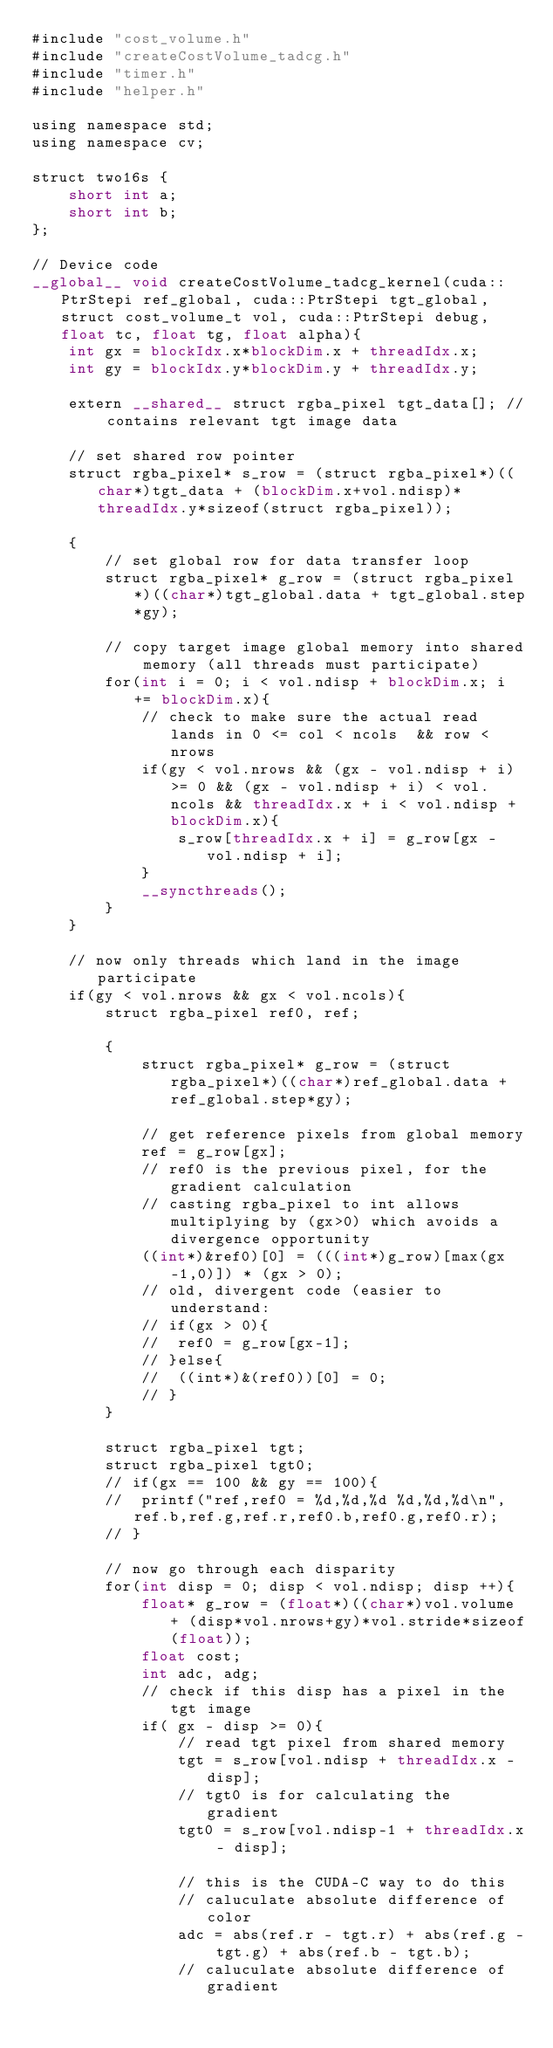<code> <loc_0><loc_0><loc_500><loc_500><_Cuda_>#include "cost_volume.h"
#include "createCostVolume_tadcg.h"
#include "timer.h"
#include "helper.h"

using namespace std;
using namespace cv;

struct two16s {
	short int a;
	short int b;
};

// Device code
__global__ void createCostVolume_tadcg_kernel(cuda::PtrStepi ref_global, cuda::PtrStepi tgt_global, struct cost_volume_t vol, cuda::PtrStepi debug, float tc, float tg, float alpha){
	int gx = blockIdx.x*blockDim.x + threadIdx.x;
	int gy = blockIdx.y*blockDim.y + threadIdx.y;

	extern __shared__ struct rgba_pixel tgt_data[]; // contains relevant tgt image data

	// set shared row pointer
	struct rgba_pixel* s_row = (struct rgba_pixel*)((char*)tgt_data + (blockDim.x+vol.ndisp)*threadIdx.y*sizeof(struct rgba_pixel));
	
	{
		// set global row for data transfer loop
		struct rgba_pixel* g_row = (struct rgba_pixel*)((char*)tgt_global.data + tgt_global.step*gy);

		// copy target image global memory into shared memory (all threads must participate)
		for(int i = 0; i < vol.ndisp + blockDim.x; i += blockDim.x){
			// check to make sure the actual read lands in 0 <= col < ncols  && row < nrows
			if(gy < vol.nrows && (gx - vol.ndisp + i) >= 0 && (gx - vol.ndisp + i) < vol.ncols && threadIdx.x + i < vol.ndisp + blockDim.x){
				s_row[threadIdx.x + i] = g_row[gx - vol.ndisp + i];
			}
			__syncthreads();
		}
	}

	// now only threads which land in the image participate
	if(gy < vol.nrows && gx < vol.ncols){
		struct rgba_pixel ref0, ref;

		{
			struct rgba_pixel* g_row = (struct rgba_pixel*)((char*)ref_global.data + ref_global.step*gy);

			// get reference pixels from global memory
			ref = g_row[gx];
			// ref0 is the previous pixel, for the gradient calculation
			// casting rgba_pixel to int allows multiplying by (gx>0) which avoids a divergence opportunity
			((int*)&ref0)[0] = (((int*)g_row)[max(gx-1,0)]) * (gx > 0);
			// old, divergent code (easier to understand:
			// if(gx > 0){
			// 	ref0 = g_row[gx-1];
			// }else{
			// 	((int*)&(ref0))[0] = 0;
			// }
		} 

		struct rgba_pixel tgt;
		struct rgba_pixel tgt0;
		// if(gx == 100 && gy == 100){
		// 	printf("ref,ref0 = %d,%d,%d %d,%d,%d\n",ref.b,ref.g,ref.r,ref0.b,ref0.g,ref0.r);
		// }

		// now go through each disparity
		for(int disp = 0; disp < vol.ndisp; disp ++){
			float* g_row = (float*)((char*)vol.volume + (disp*vol.nrows+gy)*vol.stride*sizeof(float));
			float cost;
			int adc, adg;
			// check if this disp has a pixel in the tgt image
			if( gx - disp >= 0){
				// read tgt pixel from shared memory
				tgt = s_row[vol.ndisp + threadIdx.x - disp];
				// tgt0 is for calculating the gradient
				tgt0 = s_row[vol.ndisp-1 + threadIdx.x - disp];

				// this is the CUDA-C way to do this
				// caluculate absolute difference of color
				adc = abs(ref.r - tgt.r) + abs(ref.g - tgt.g) + abs(ref.b - tgt.b);
				// caluculate absolute difference of gradient</code> 